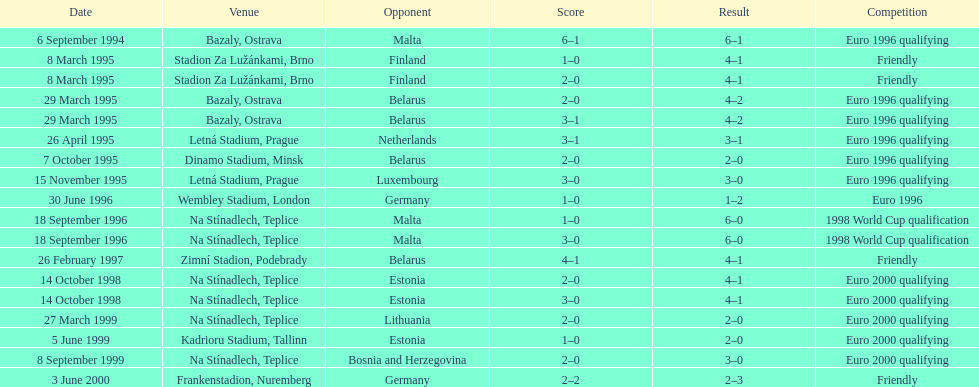List the opponent in which the result was the least out of all the results. Germany. 